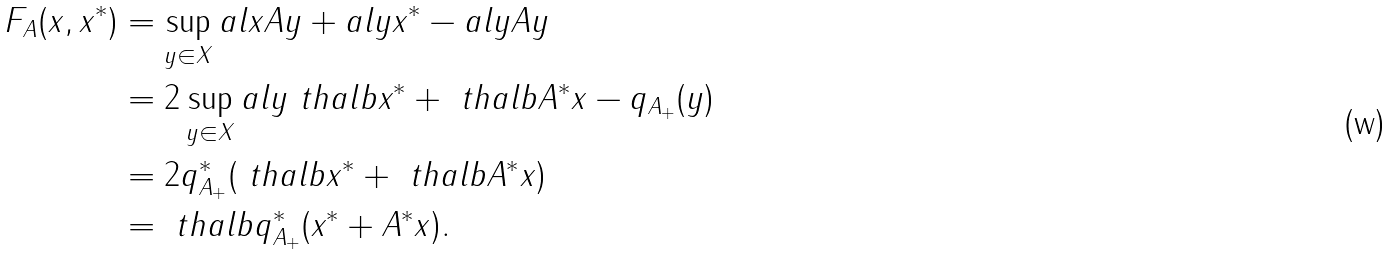Convert formula to latex. <formula><loc_0><loc_0><loc_500><loc_500>F _ { A } ( x , x ^ { * } ) & = \sup _ { y \in X } a l { x } { A y } + a l { y } { x ^ { * } } - a l { y } { A y } \\ & = 2 \sup _ { y \in X } a l { y } { \ t h a l b x ^ { * } + \ t h a l b A ^ { * } x } - q _ { A _ { + } } ( y ) \\ & = 2 q _ { A _ { + } } ^ { * } ( \ t h a l b x ^ { * } + \ t h a l b A ^ { * } x ) \\ & = \ t h a l b q _ { A _ { + } } ^ { * } ( x ^ { * } + A ^ { * } x ) .</formula> 